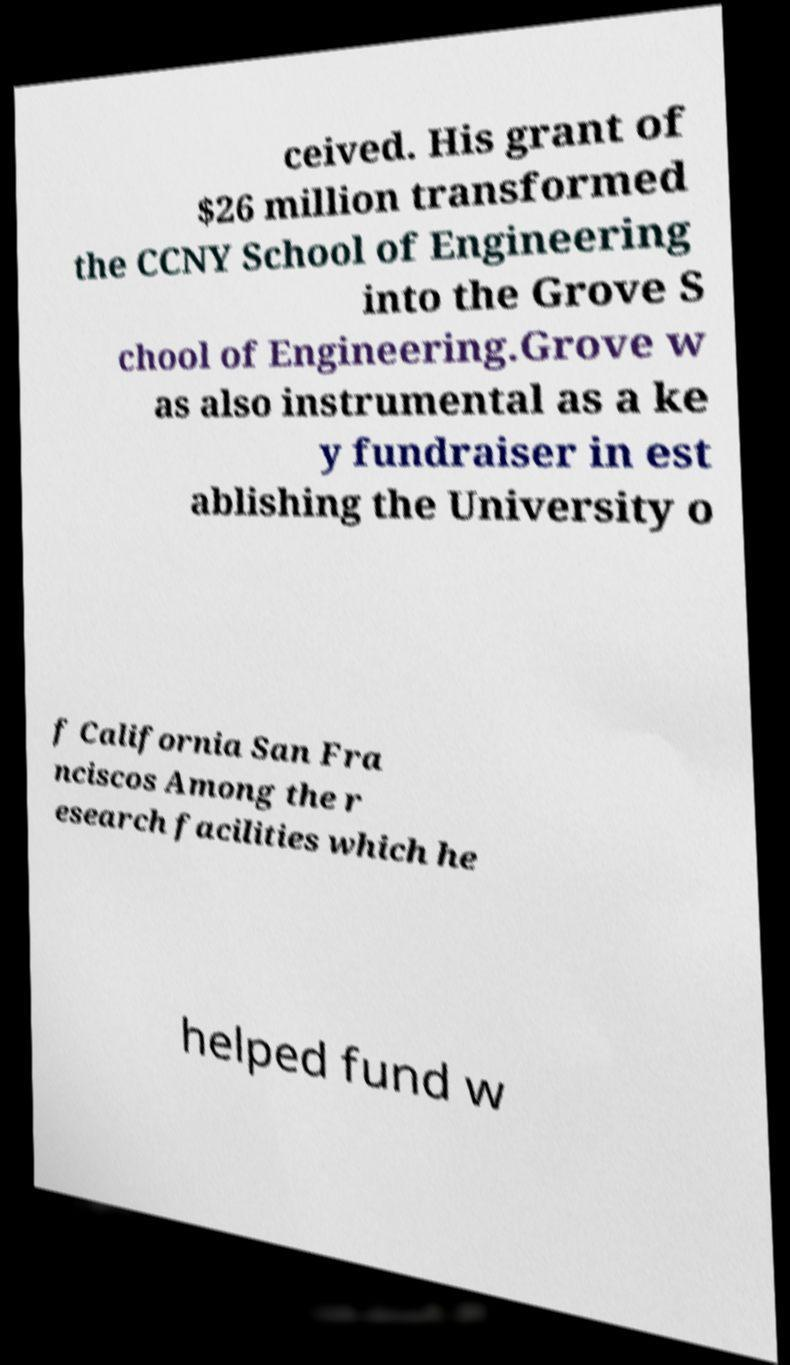I need the written content from this picture converted into text. Can you do that? ceived. His grant of $26 million transformed the CCNY School of Engineering into the Grove S chool of Engineering.Grove w as also instrumental as a ke y fundraiser in est ablishing the University o f California San Fra nciscos Among the r esearch facilities which he helped fund w 